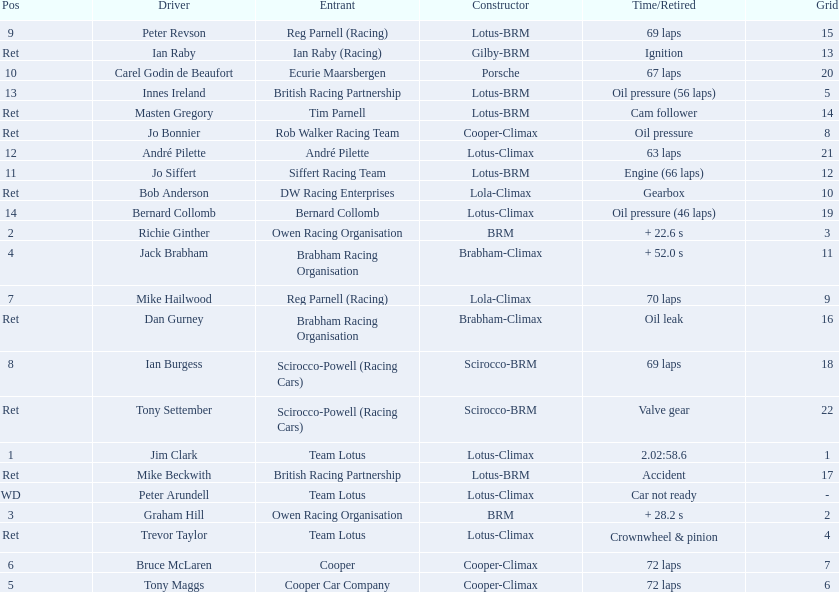Who were the drivers in the the 1963 international gold cup? Jim Clark, Richie Ginther, Graham Hill, Jack Brabham, Tony Maggs, Bruce McLaren, Mike Hailwood, Ian Burgess, Peter Revson, Carel Godin de Beaufort, Jo Siffert, André Pilette, Innes Ireland, Bernard Collomb, Ian Raby, Dan Gurney, Mike Beckwith, Masten Gregory, Trevor Taylor, Jo Bonnier, Tony Settember, Bob Anderson, Peter Arundell. Which drivers drove a cooper-climax car? Tony Maggs, Bruce McLaren, Jo Bonnier. What did these drivers place? 5, 6, Ret. What was the best placing position? 5. Who was the driver with this placing? Tony Maggs. 